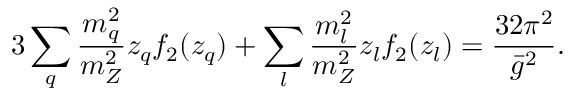Convert formula to latex. <formula><loc_0><loc_0><loc_500><loc_500>3 \sum _ { q } { \frac { m _ { q } ^ { 2 } } { m _ { Z } ^ { 2 } } } z _ { q } f _ { 2 } ( z _ { q } ) + \sum _ { l } { \frac { m _ { l } ^ { 2 } } { m _ { Z } ^ { 2 } } } z _ { l } f _ { 2 } ( z _ { l } ) = { \frac { 3 2 \pi ^ { 2 } } { \bar { g } ^ { 2 } } } .</formula> 